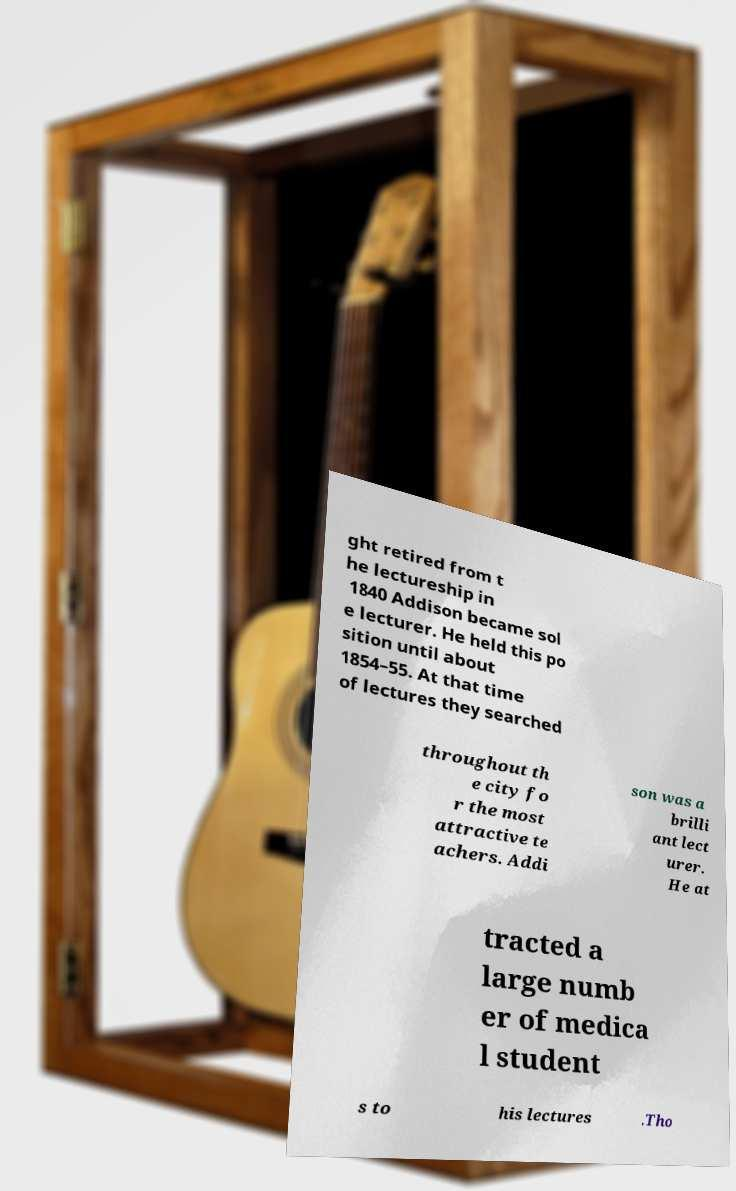I need the written content from this picture converted into text. Can you do that? ght retired from t he lectureship in 1840 Addison became sol e lecturer. He held this po sition until about 1854–55. At that time of lectures they searched throughout th e city fo r the most attractive te achers. Addi son was a brilli ant lect urer. He at tracted a large numb er of medica l student s to his lectures .Tho 